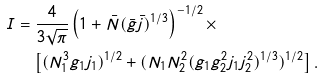<formula> <loc_0><loc_0><loc_500><loc_500>I & = \frac { 4 } { 3 \sqrt { \pi } } \left ( 1 + \bar { N } ( \bar { g } \bar { j } ) ^ { 1 / 3 } \right ) ^ { - 1 / 2 } \times \\ & \quad \left [ ( N _ { 1 } ^ { 3 } g _ { 1 } j _ { 1 } ) ^ { 1 / 2 } + ( N _ { 1 } N _ { 2 } ^ { 2 } ( g _ { 1 } g _ { 2 } ^ { 2 } j _ { 1 } j _ { 2 } ^ { 2 } ) ^ { 1 / 3 } ) ^ { 1 / 2 } \right ] .</formula> 